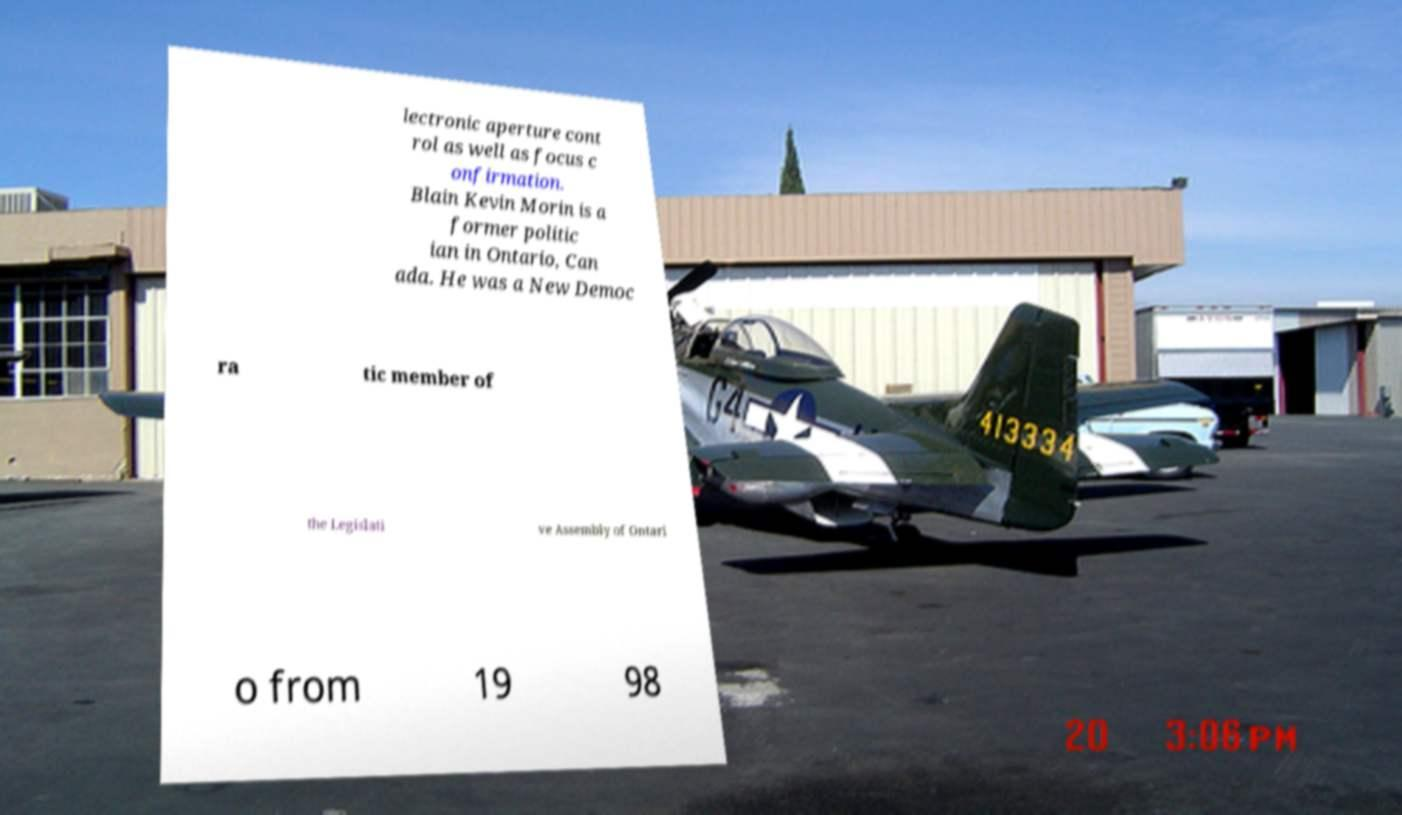Can you accurately transcribe the text from the provided image for me? lectronic aperture cont rol as well as focus c onfirmation. Blain Kevin Morin is a former politic ian in Ontario, Can ada. He was a New Democ ra tic member of the Legislati ve Assembly of Ontari o from 19 98 